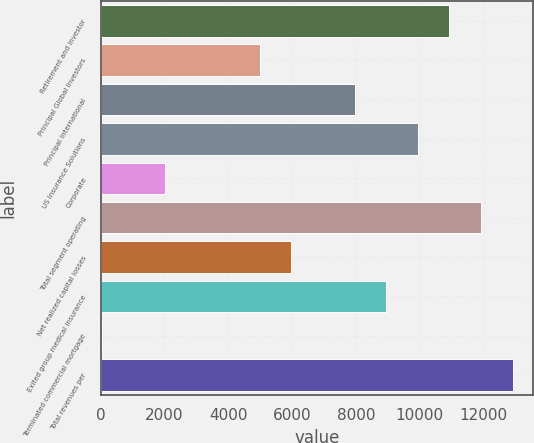<chart> <loc_0><loc_0><loc_500><loc_500><bar_chart><fcel>Retirement and Investor<fcel>Principal Global Investors<fcel>Principal International<fcel>US Insurance Solutions<fcel>Corporate<fcel>Total segment operating<fcel>Net realized capital losses<fcel>Exited group medical insurance<fcel>Terminated commercial mortgage<fcel>Total revenues per<nl><fcel>10926.3<fcel>4984.05<fcel>7955.16<fcel>9935.9<fcel>2012.94<fcel>11916.6<fcel>5974.42<fcel>8945.53<fcel>32.2<fcel>12907<nl></chart> 